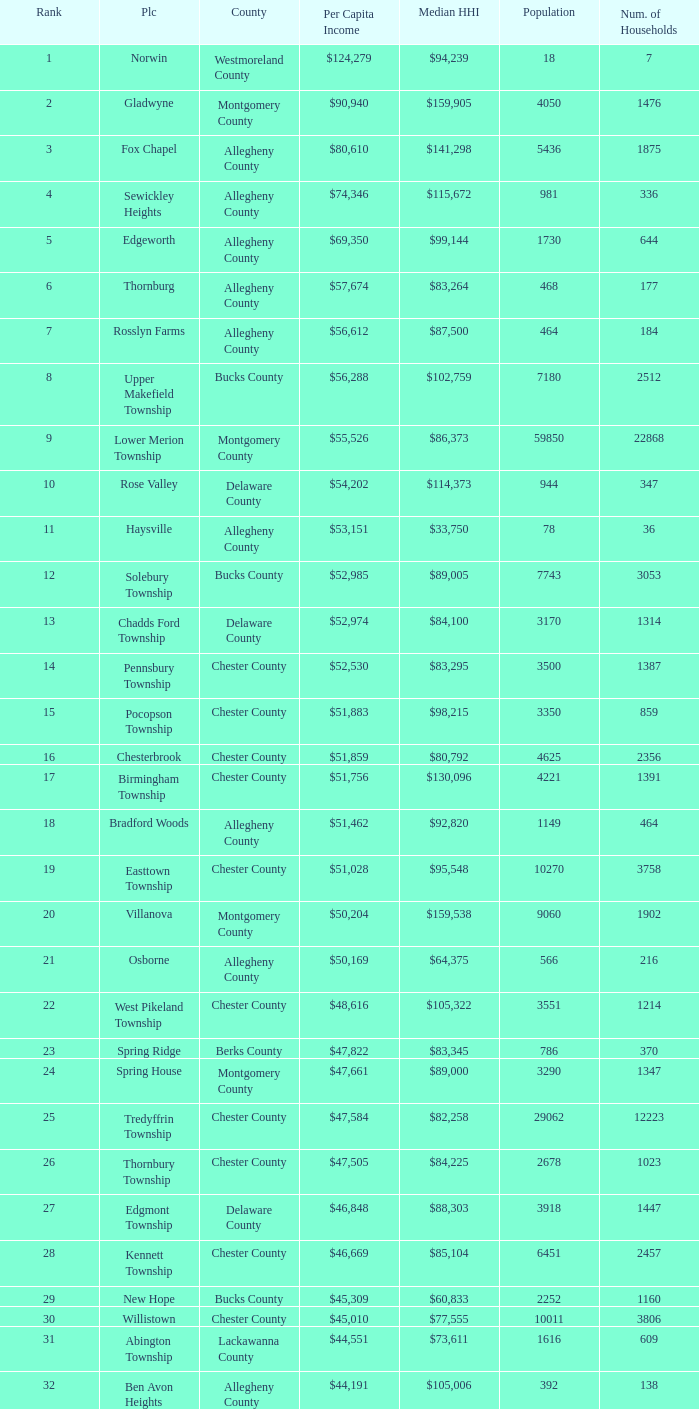What county has 2053 households?  Chester County. 